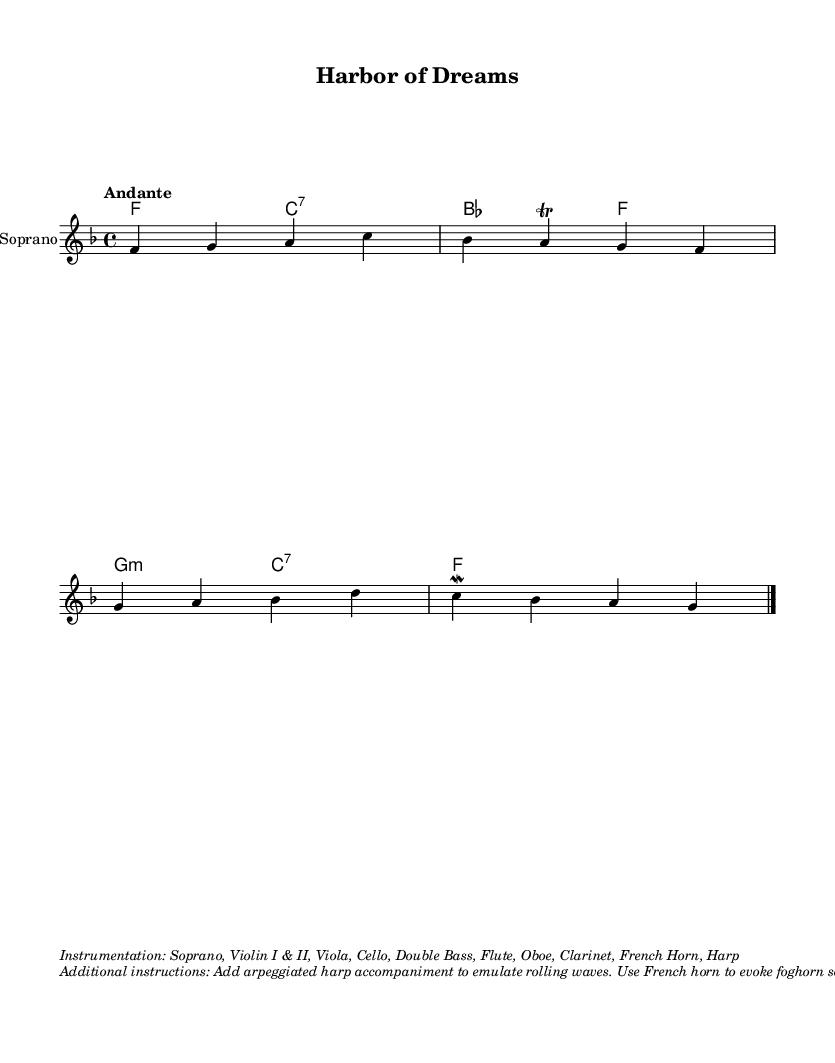What is the key signature of this music? The key signature is F major, which has one flat (B flat). You can identify it by looking at the key signature indicated at the beginning of the sheet music.
Answer: F major What is the time signature of this music? The time signature is 4/4, which is indicated at the beginning of the score following the clef and key signature. This means there are four beats in each measure.
Answer: 4/4 What is the tempo marking for this piece? The tempo marking is "Andante", which is typically understood to mean a moderately slow tempo. It is written above the staff at the start of the piece.
Answer: Andante How many measures are in the melody section? There are four measures in the melody section, as can be counted by the number of vertical bar lines separating the measures in the staff.
Answer: 4 What is the instrumentation specified for this piece? The instrumentation includes Soprano, Violin I & II, Viola, Cello, Double Bass, Flute, Oboe, Clarinet, French Horn, and Harp. This information is given in the markup section underneath the score.
Answer: Soprano, Violin I & II, Viola, Cello, Double Bass, Flute, Oboe, Clarinet, French Horn, Harp What type of accompaniment is suggested for the harp? The accompaniment suggested for the harp is to add arpeggiated patterns to emulate rolling waves, as indicated in the additional instructions section.
Answer: Arpeggiated What is the primary theme conveyed in the lyrics? The primary theme conveyed in the lyrics is about dreaming and the serene interaction between the harbor, ships, and the emotions of the heart, as seen in the imagery of the text.
Answer: Dreaming and love 